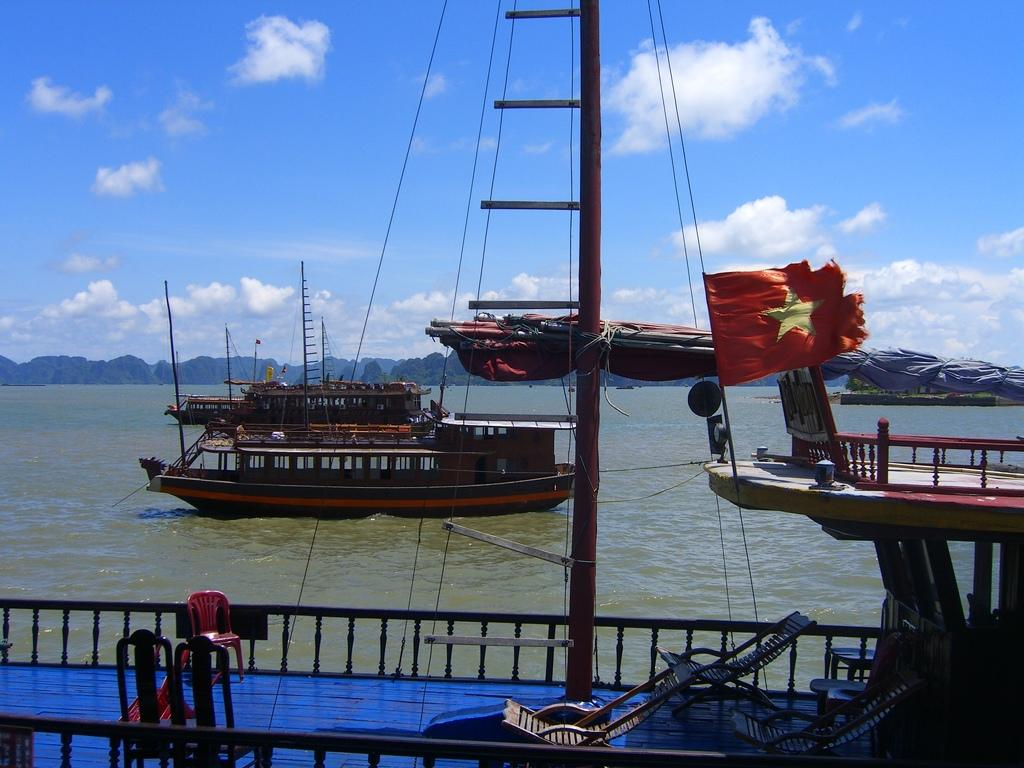What can be seen in the sky in the background of the image? There are clouds in the sky in the background of the image. What other elements are visible in the background of the image? There are trees and water visible in the background of the image. What type of vehicles can be seen in the image? There are ships in the image. Are there any objects with specific designs or symbols in the image? Yes, there are flags in the image. What type of furniture is present in the image? There are chairs in the image. What type of crime is being committed in the image? There is no crime being committed in the image; it features ships, flags, and chairs in a natural setting. Can you tell me how many hearts are visible in the image? There are no hearts visible in the image. 